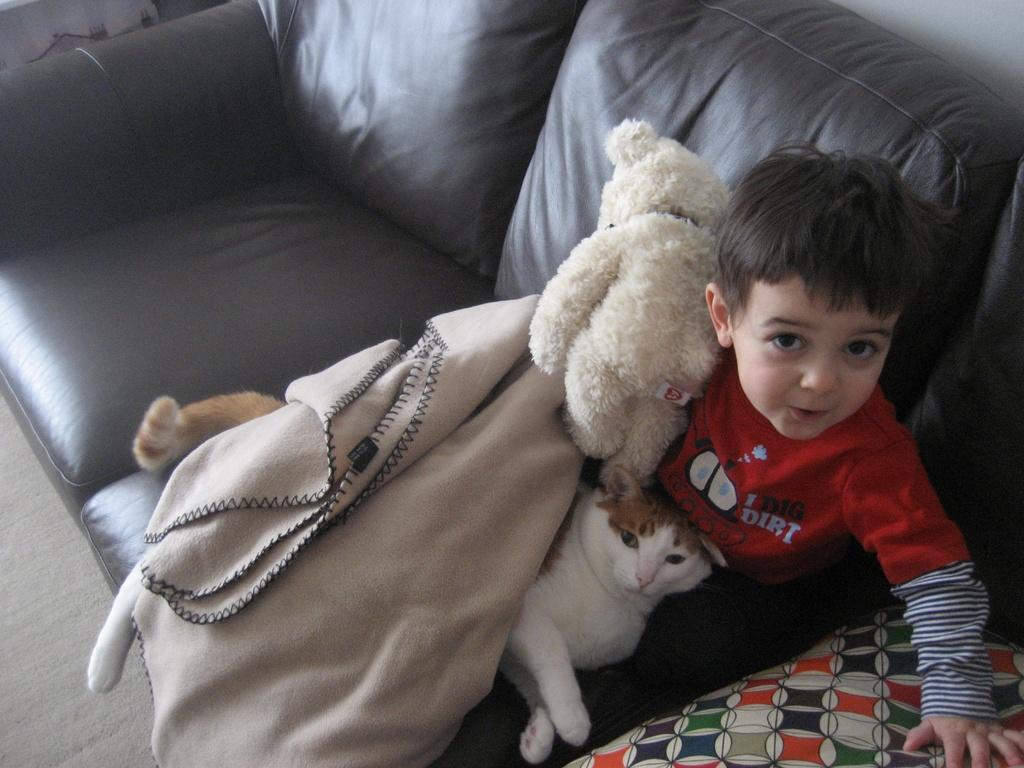What type of furniture is in the image? There is a sofa in the image. Who or what is sitting on the sofa? A boy is seated on the sofa. What other living creature is present in the image? There is a cat in the image. What type of object can be seen in the image? There is a toy in the image. What theory does the boy present to the cat in the image? There is no indication in the image that the boy is presenting a theory to the cat. 